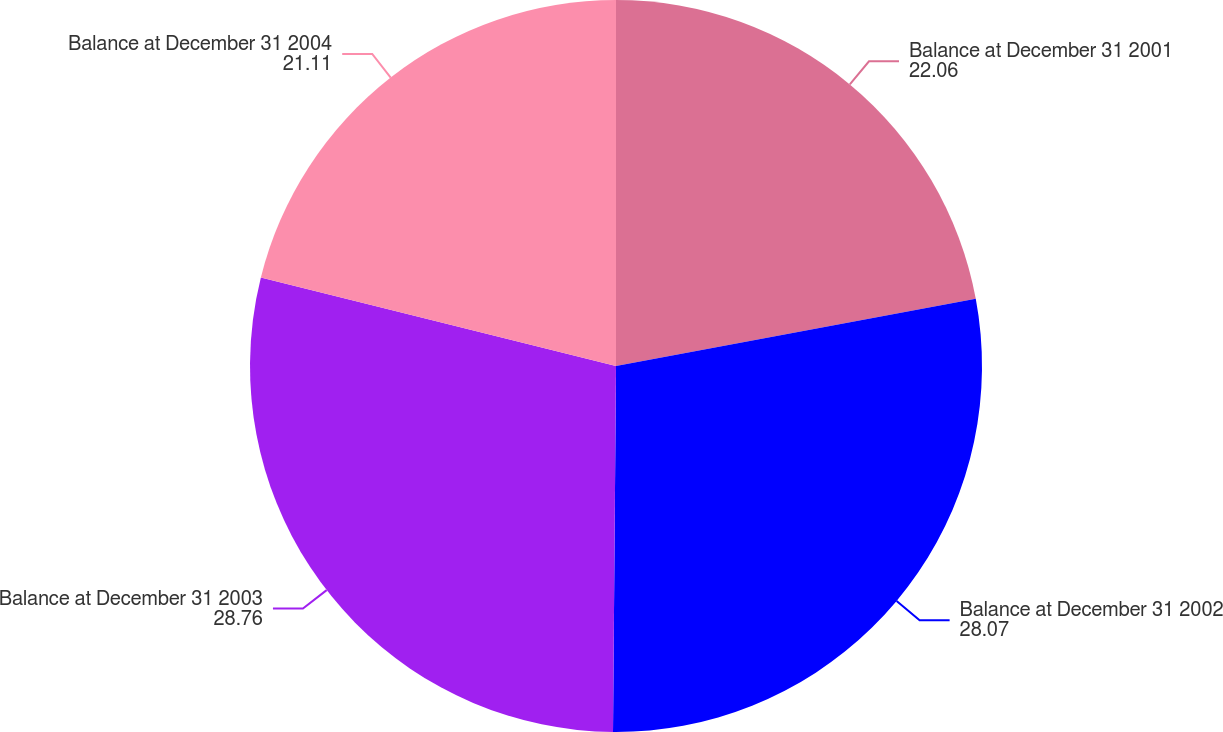Convert chart to OTSL. <chart><loc_0><loc_0><loc_500><loc_500><pie_chart><fcel>Balance at December 31 2001<fcel>Balance at December 31 2002<fcel>Balance at December 31 2003<fcel>Balance at December 31 2004<nl><fcel>22.06%<fcel>28.07%<fcel>28.76%<fcel>21.11%<nl></chart> 